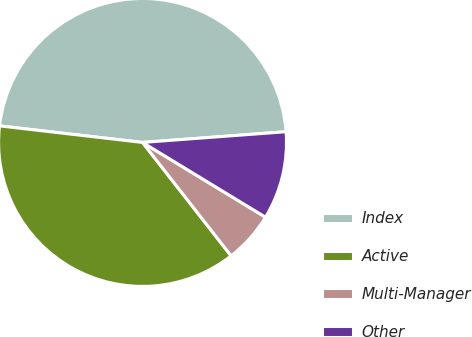Convert chart. <chart><loc_0><loc_0><loc_500><loc_500><pie_chart><fcel>Index<fcel>Active<fcel>Multi-Manager<fcel>Other<nl><fcel>46.98%<fcel>37.39%<fcel>5.75%<fcel>9.88%<nl></chart> 